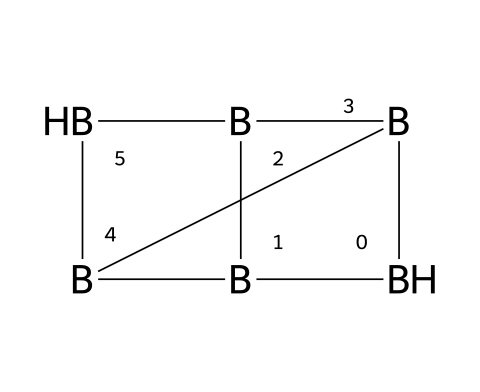What is the molecular formula of pentaborane? By analyzing the structure represented by the SMILES notation, we can determine the number of boron atoms in the compound. The notation indicates a structure showing five boron atoms. Therefore, the molecular formula is B5H11, which can be derived from knowing that each boron typically bonds with hydrogen to satisfy valency.
Answer: B5H11 How many boron atoms are present in pentaborane? The SMILES representation indicates multiple boron atoms arranged in a specific structure. Counting these indicates there are five boron atoms in total within the molecular structure.
Answer: 5 What type of intermolecular forces are primarily present in pentaborane? The primary intermolecular forces in pentaborane are van der Waals forces. Given the presence of boron and hydrogen, there are no significant dipole moments or hydrogen bonds in the molecule; the interactions are primarily due to transient induced dipoles between molecules.
Answer: van der Waals forces What is the coordinate geometry around boron in pentaborane? The geometric arrangement around boron atoms in pentaborane is influenced by their hybridization states. Each boron shows a certain level of sp3 hybridization, leading to a distorted tetrahedral geometrical arrangement due to the presence of fewer electrons compared to standard tetrahedral arrangements.
Answer: distorted tetrahedral What is the significance of pentaborane in aviation fuels? In the mid-20th century, pentaborane was explored as a potential aviation fuel due to its high energy content and specific combustion properties. Its unique molecular structure allows for greater energy release, making it a candidate for high-performance fuels in aerospace applications.
Answer: high energy content 